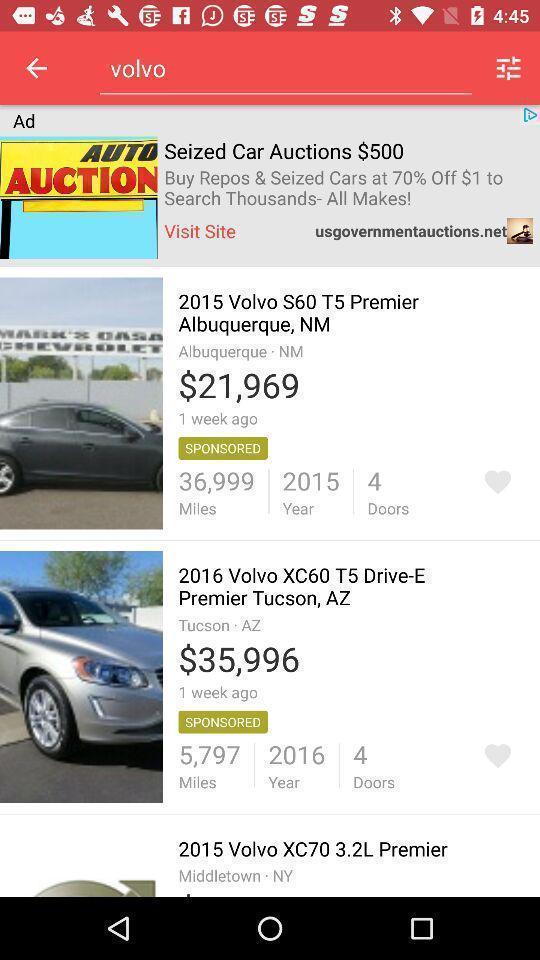Tell me what you see in this picture. Screen shows multiple options in a shopping application. 